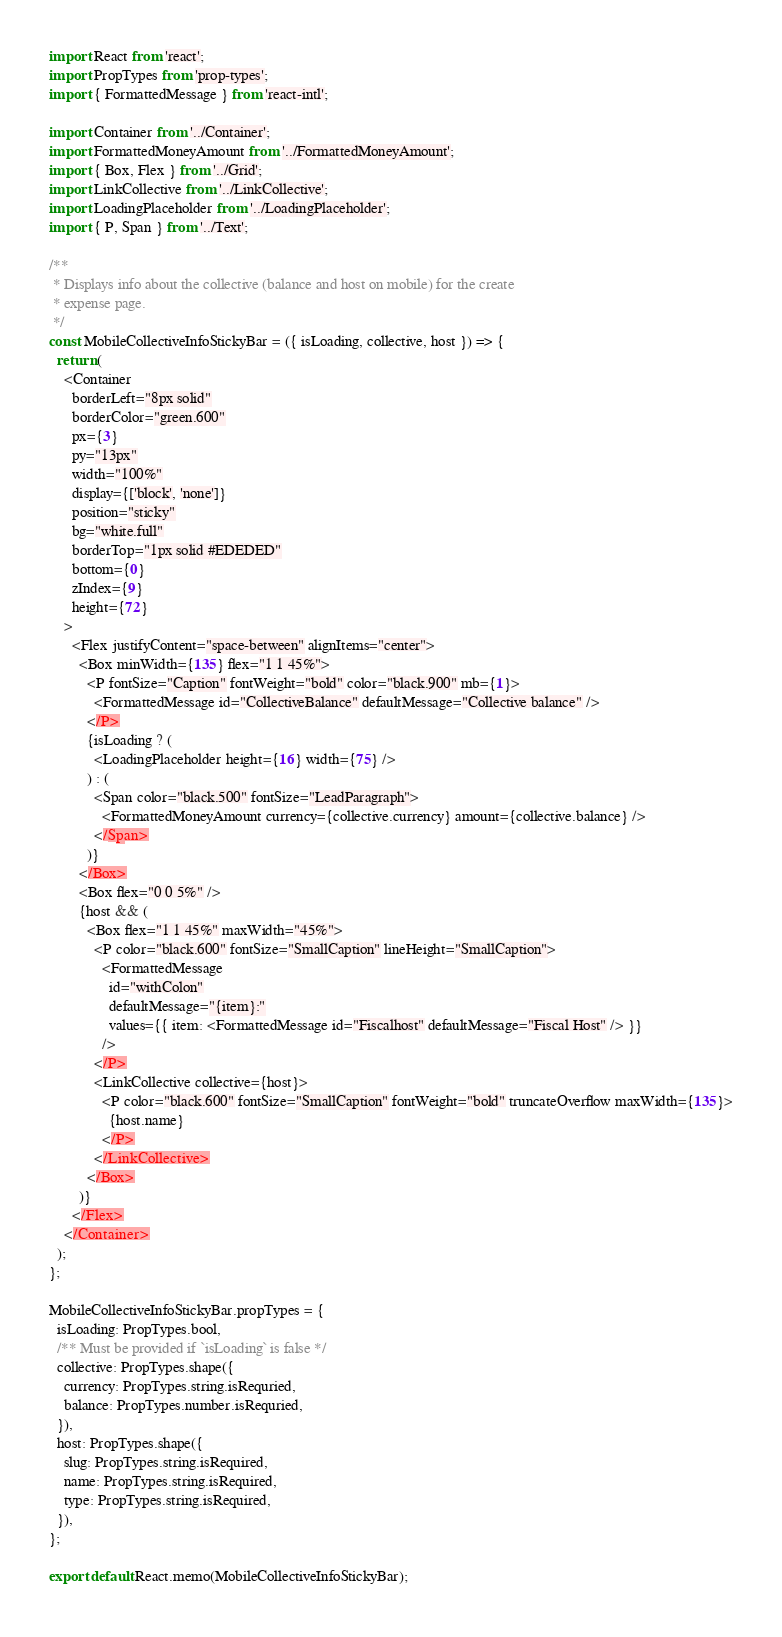<code> <loc_0><loc_0><loc_500><loc_500><_JavaScript_>import React from 'react';
import PropTypes from 'prop-types';
import { FormattedMessage } from 'react-intl';

import Container from '../Container';
import FormattedMoneyAmount from '../FormattedMoneyAmount';
import { Box, Flex } from '../Grid';
import LinkCollective from '../LinkCollective';
import LoadingPlaceholder from '../LoadingPlaceholder';
import { P, Span } from '../Text';

/**
 * Displays info about the collective (balance and host on mobile) for the create
 * expense page.
 */
const MobileCollectiveInfoStickyBar = ({ isLoading, collective, host }) => {
  return (
    <Container
      borderLeft="8px solid"
      borderColor="green.600"
      px={3}
      py="13px"
      width="100%"
      display={['block', 'none']}
      position="sticky"
      bg="white.full"
      borderTop="1px solid #EDEDED"
      bottom={0}
      zIndex={9}
      height={72}
    >
      <Flex justifyContent="space-between" alignItems="center">
        <Box minWidth={135} flex="1 1 45%">
          <P fontSize="Caption" fontWeight="bold" color="black.900" mb={1}>
            <FormattedMessage id="CollectiveBalance" defaultMessage="Collective balance" />
          </P>
          {isLoading ? (
            <LoadingPlaceholder height={16} width={75} />
          ) : (
            <Span color="black.500" fontSize="LeadParagraph">
              <FormattedMoneyAmount currency={collective.currency} amount={collective.balance} />
            </Span>
          )}
        </Box>
        <Box flex="0 0 5%" />
        {host && (
          <Box flex="1 1 45%" maxWidth="45%">
            <P color="black.600" fontSize="SmallCaption" lineHeight="SmallCaption">
              <FormattedMessage
                id="withColon"
                defaultMessage="{item}:"
                values={{ item: <FormattedMessage id="Fiscalhost" defaultMessage="Fiscal Host" /> }}
              />
            </P>
            <LinkCollective collective={host}>
              <P color="black.600" fontSize="SmallCaption" fontWeight="bold" truncateOverflow maxWidth={135}>
                {host.name}
              </P>
            </LinkCollective>
          </Box>
        )}
      </Flex>
    </Container>
  );
};

MobileCollectiveInfoStickyBar.propTypes = {
  isLoading: PropTypes.bool,
  /** Must be provided if `isLoading` is false */
  collective: PropTypes.shape({
    currency: PropTypes.string.isRequried,
    balance: PropTypes.number.isRequried,
  }),
  host: PropTypes.shape({
    slug: PropTypes.string.isRequired,
    name: PropTypes.string.isRequired,
    type: PropTypes.string.isRequired,
  }),
};

export default React.memo(MobileCollectiveInfoStickyBar);
</code> 